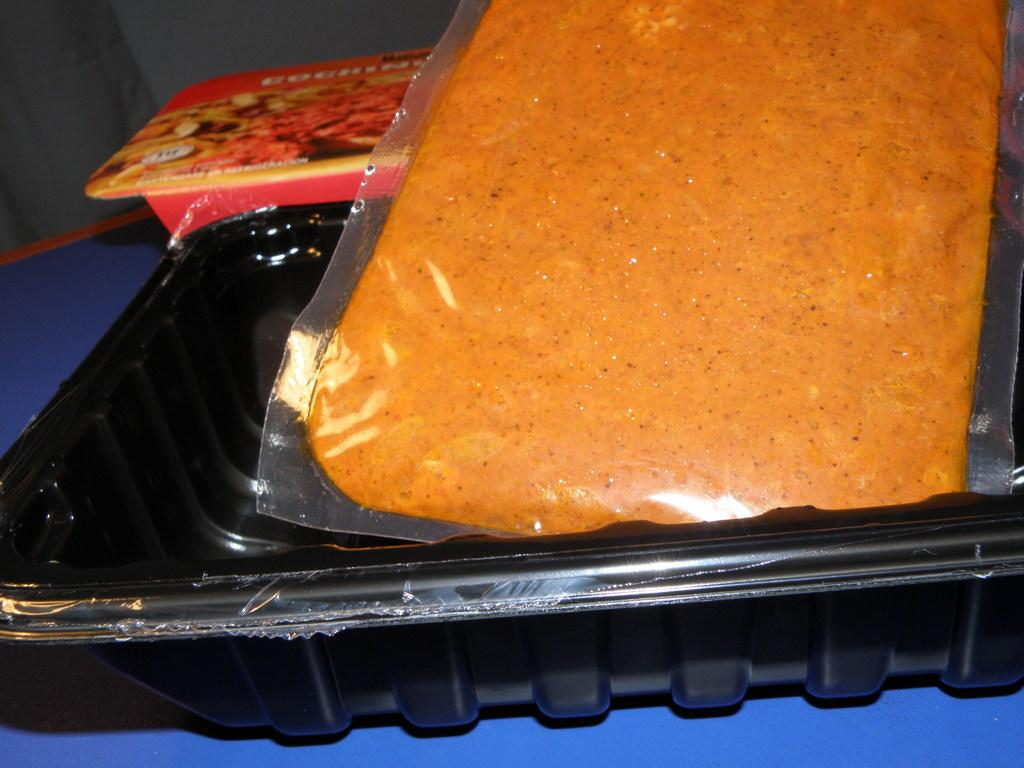What color is the bowl with food in the image? The bowl with food is black. Are there any other bowls in the image? Yes, there is a red bowl in the image. Where is the red bowl located? The red bowl is placed on a surface. How many babies are present in the image? There are no babies present in the image; it only features bowls. 